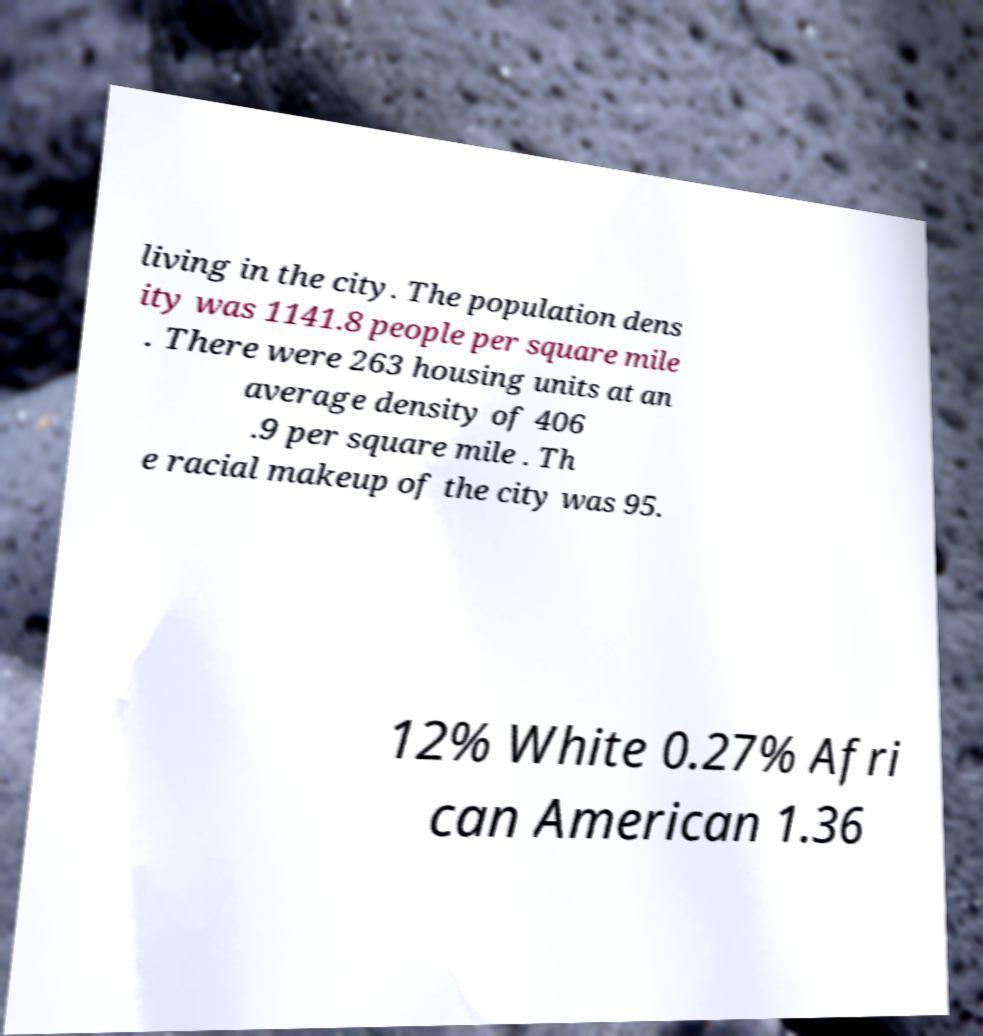I need the written content from this picture converted into text. Can you do that? living in the city. The population dens ity was 1141.8 people per square mile . There were 263 housing units at an average density of 406 .9 per square mile . Th e racial makeup of the city was 95. 12% White 0.27% Afri can American 1.36 